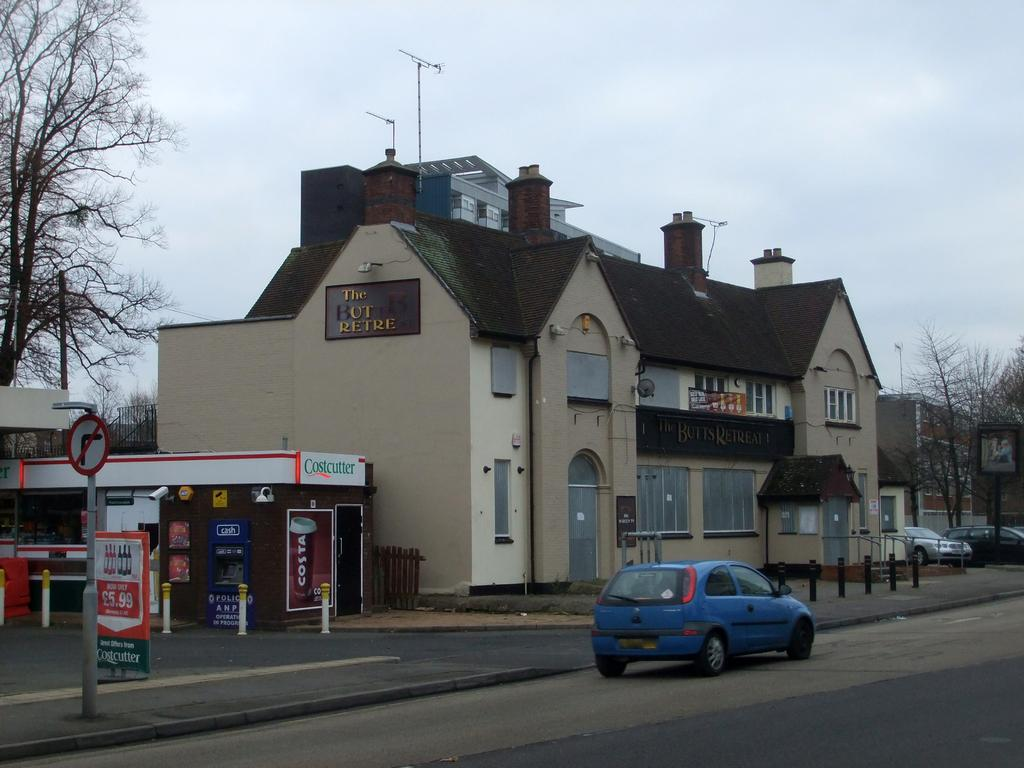What is the main feature of the image? There is a road in the image. What is happening on the road? There are vehicles on the road. What else can be seen in the image besides the road and vehicles? There are poles, boards, trees, buildings, and the sky visible in the image. What type of dirt can be seen on the teeth of the person in the image? There is no person present in the image, and therefore no teeth or dirt on teeth can be observed. 